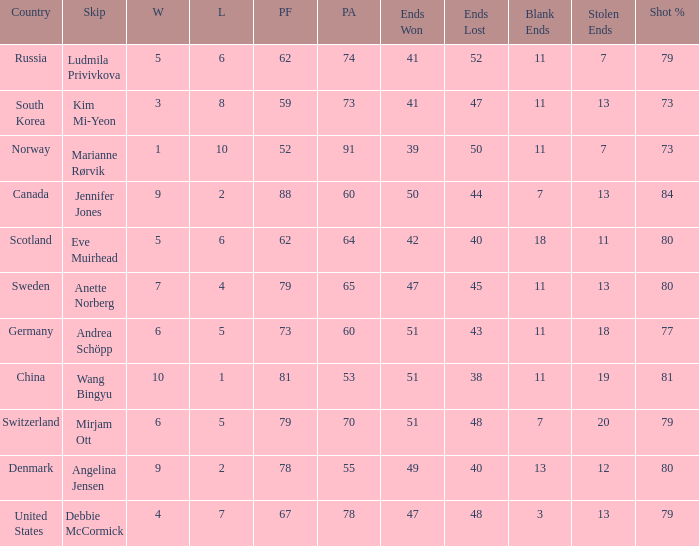Can you give me this table as a dict? {'header': ['Country', 'Skip', 'W', 'L', 'PF', 'PA', 'Ends Won', 'Ends Lost', 'Blank Ends', 'Stolen Ends', 'Shot %'], 'rows': [['Russia', 'Ludmila Privivkova', '5', '6', '62', '74', '41', '52', '11', '7', '79'], ['South Korea', 'Kim Mi-Yeon', '3', '8', '59', '73', '41', '47', '11', '13', '73'], ['Norway', 'Marianne Rørvik', '1', '10', '52', '91', '39', '50', '11', '7', '73'], ['Canada', 'Jennifer Jones', '9', '2', '88', '60', '50', '44', '7', '13', '84'], ['Scotland', 'Eve Muirhead', '5', '6', '62', '64', '42', '40', '18', '11', '80'], ['Sweden', 'Anette Norberg', '7', '4', '79', '65', '47', '45', '11', '13', '80'], ['Germany', 'Andrea Schöpp', '6', '5', '73', '60', '51', '43', '11', '18', '77'], ['China', 'Wang Bingyu', '10', '1', '81', '53', '51', '38', '11', '19', '81'], ['Switzerland', 'Mirjam Ott', '6', '5', '79', '70', '51', '48', '7', '20', '79'], ['Denmark', 'Angelina Jensen', '9', '2', '78', '55', '49', '40', '13', '12', '80'], ['United States', 'Debbie McCormick', '4', '7', '67', '78', '47', '48', '3', '13', '79']]} What is the minimum Wins a team has? 1.0. 